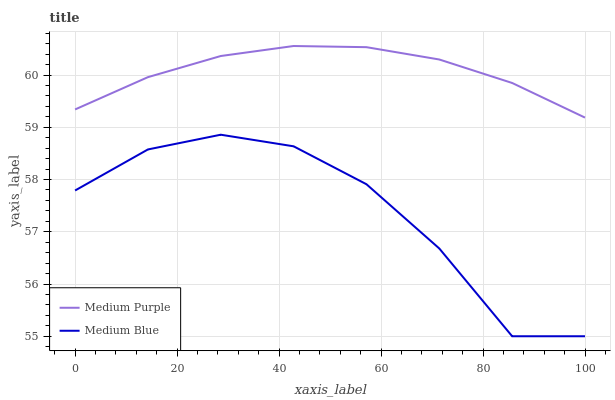Does Medium Blue have the minimum area under the curve?
Answer yes or no. Yes. Does Medium Purple have the maximum area under the curve?
Answer yes or no. Yes. Does Medium Blue have the maximum area under the curve?
Answer yes or no. No. Is Medium Purple the smoothest?
Answer yes or no. Yes. Is Medium Blue the roughest?
Answer yes or no. Yes. Is Medium Blue the smoothest?
Answer yes or no. No. Does Medium Blue have the lowest value?
Answer yes or no. Yes. Does Medium Purple have the highest value?
Answer yes or no. Yes. Does Medium Blue have the highest value?
Answer yes or no. No. Is Medium Blue less than Medium Purple?
Answer yes or no. Yes. Is Medium Purple greater than Medium Blue?
Answer yes or no. Yes. Does Medium Blue intersect Medium Purple?
Answer yes or no. No. 